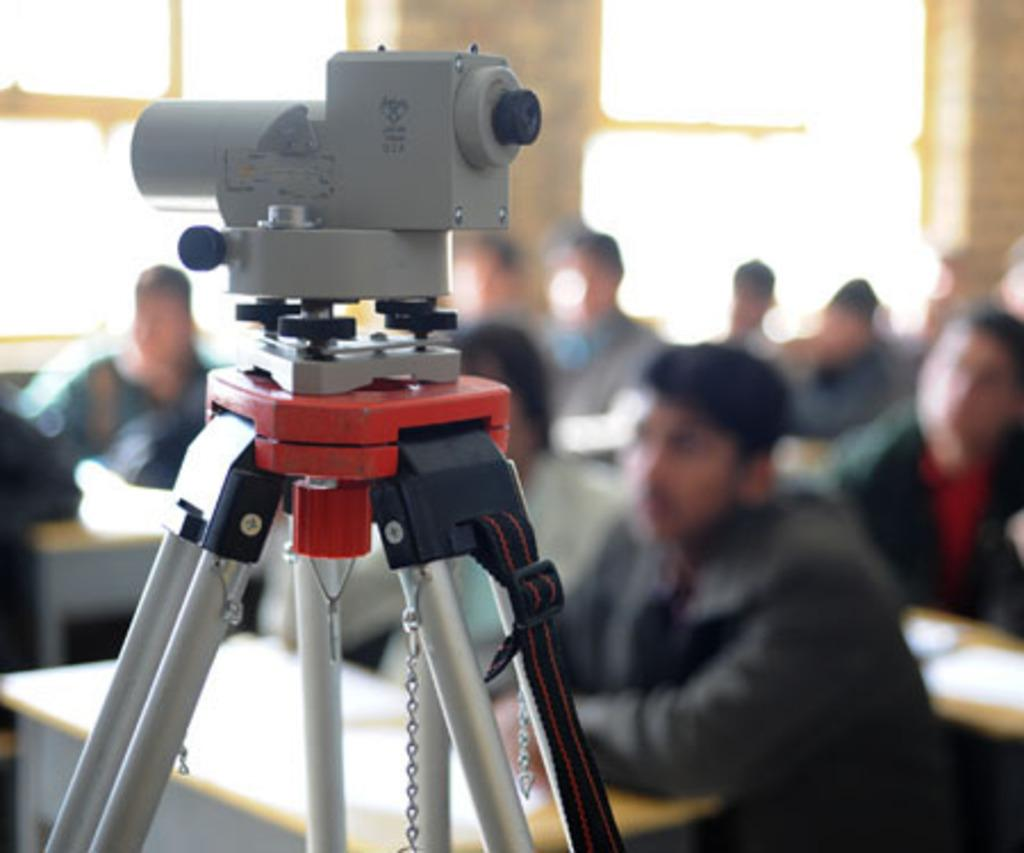What are the people in the image doing? The people in the image are seated. What objects are present in the image besides the people? There are tables and an area measuring machine on a stand in the image. Are there any papers visible in the image? Yes, there are papers on one of the tables. What scent can be detected from the people in the image? There is no information about the scent of the people in the image, so it cannot be determined. 